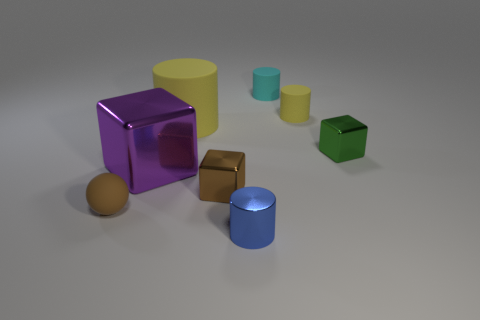What number of brown objects are either metal things or metal cylinders?
Provide a short and direct response. 1. How many other things are the same color as the tiny metal cylinder?
Keep it short and to the point. 0. Are there fewer tiny blue shiny cylinders behind the brown cube than small metallic things?
Keep it short and to the point. Yes. There is a block on the right side of the tiny shiny block in front of the tiny shiny block that is behind the brown shiny block; what is its color?
Your answer should be compact. Green. The cyan object that is the same shape as the blue shiny object is what size?
Offer a terse response. Small. Are there fewer small brown rubber things that are left of the metal cylinder than objects that are behind the rubber ball?
Your answer should be compact. Yes. The small rubber thing that is on the left side of the small yellow thing and right of the sphere has what shape?
Keep it short and to the point. Cylinder. There is a ball that is made of the same material as the big yellow cylinder; what is its size?
Make the answer very short. Small. Does the matte ball have the same color as the block in front of the big purple thing?
Ensure brevity in your answer.  Yes. There is a cube that is to the right of the large rubber cylinder and in front of the tiny green shiny cube; what is it made of?
Keep it short and to the point. Metal. 